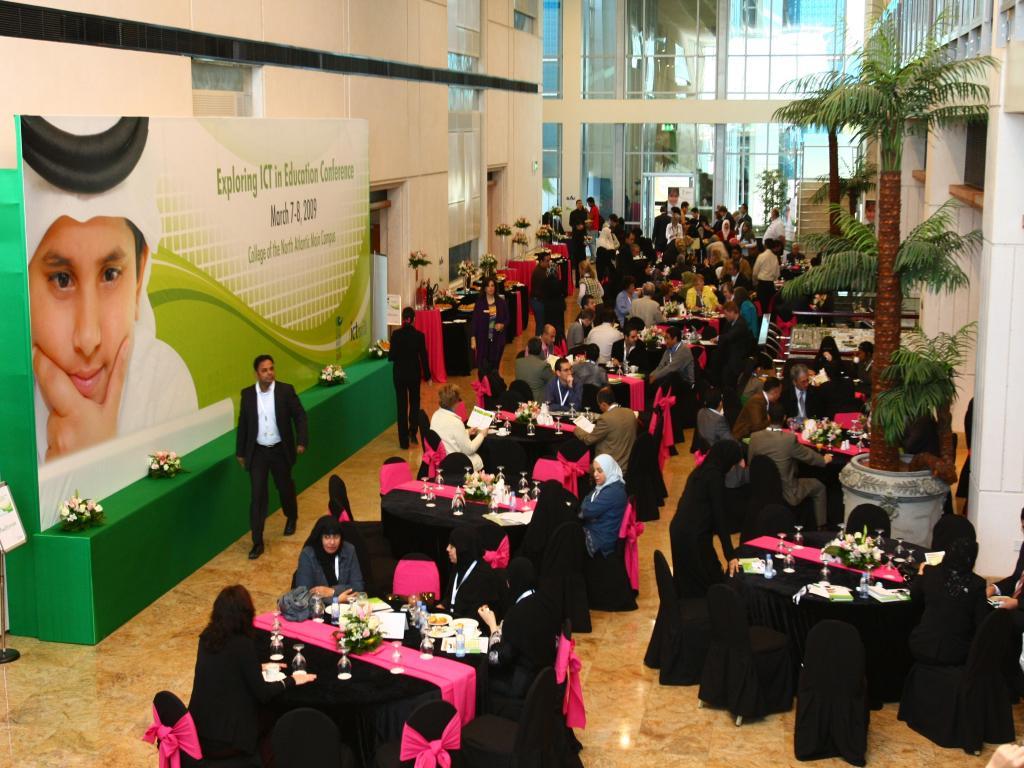Describe this image in one or two sentences. This image is taken in a building. Towards the left there is a board, a kid photograph is printed on it. Besides the board there is a man walking. The building is filled with tables, chairs and some people. People are sitting around the table. Towards the right corner there is a plastic tree, towards the right bottom there are empty tables and chairs. 